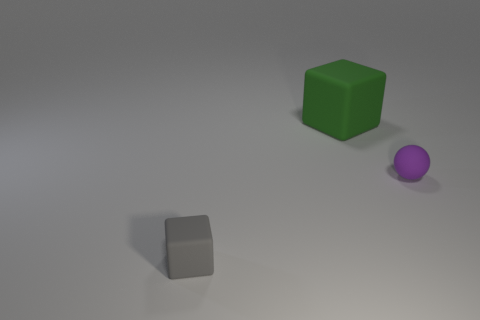How many brown shiny cubes are there?
Give a very brief answer. 0. Is there any other thing that is the same shape as the purple thing?
Ensure brevity in your answer.  No. Does the block left of the large green object have the same material as the small object right of the green block?
Your response must be concise. Yes. What is the tiny sphere made of?
Make the answer very short. Rubber. What number of tiny gray things have the same material as the large block?
Your response must be concise. 1. What number of metallic things are either small cyan cubes or large green blocks?
Your answer should be very brief. 0. Do the small thing that is in front of the purple ball and the large rubber object behind the tiny purple matte object have the same shape?
Keep it short and to the point. Yes. There is a rubber object that is both in front of the big green thing and behind the gray object; what is its color?
Provide a succinct answer. Purple. Is the size of the rubber thing left of the big green thing the same as the matte cube right of the small gray thing?
Ensure brevity in your answer.  No. What number of other small cubes are the same color as the tiny rubber block?
Ensure brevity in your answer.  0. 